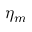<formula> <loc_0><loc_0><loc_500><loc_500>\eta _ { m }</formula> 